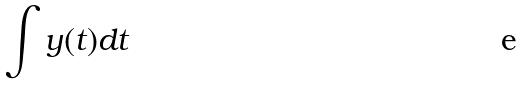<formula> <loc_0><loc_0><loc_500><loc_500>\int y ( t ) d t</formula> 